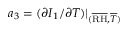<formula> <loc_0><loc_0><loc_500><loc_500>a _ { 3 } = ( \partial I _ { 1 } / \partial T ) | _ { ( \overline { R H } , \overline { T } ) }</formula> 